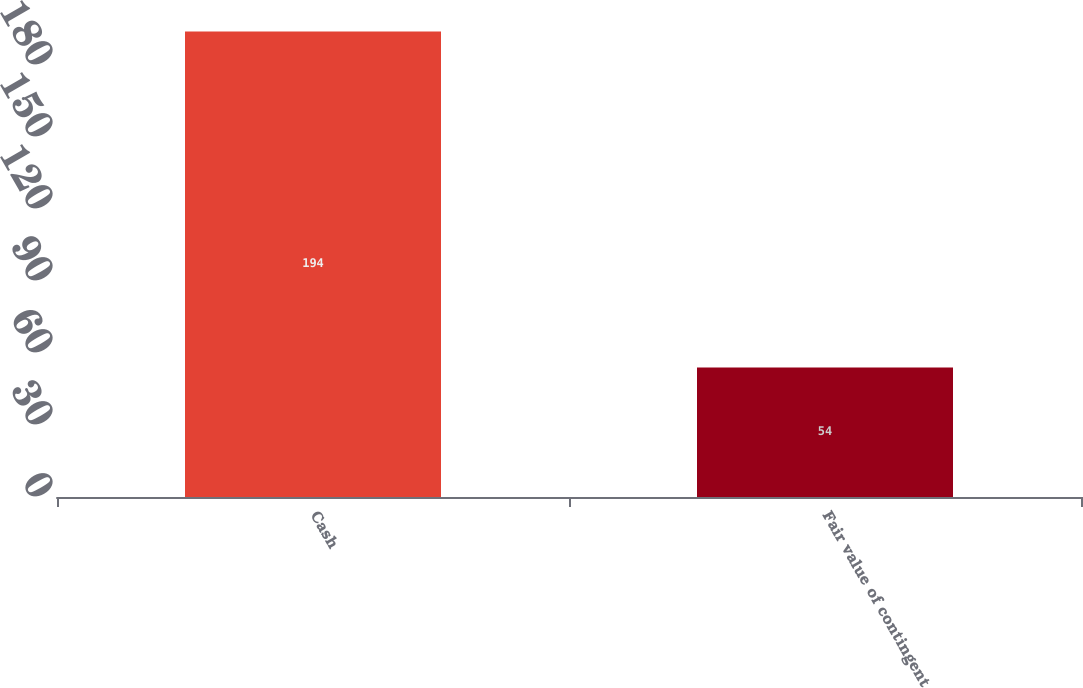<chart> <loc_0><loc_0><loc_500><loc_500><bar_chart><fcel>Cash<fcel>Fair value of contingent<nl><fcel>194<fcel>54<nl></chart> 